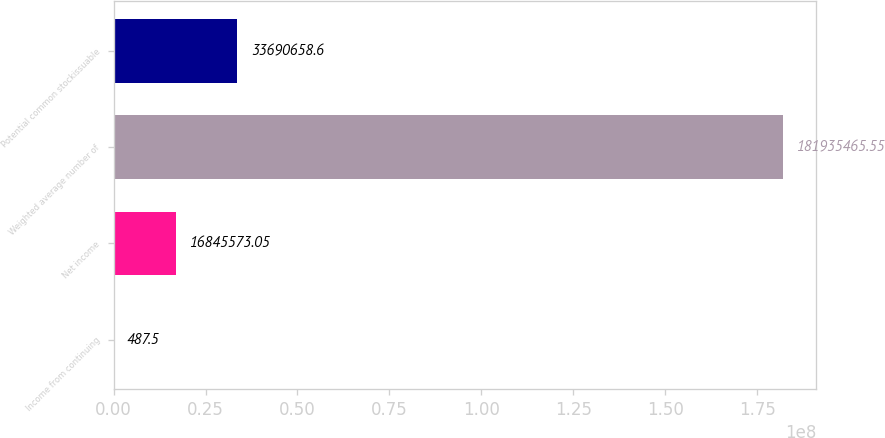Convert chart to OTSL. <chart><loc_0><loc_0><loc_500><loc_500><bar_chart><fcel>Income from continuing<fcel>Net income<fcel>Weighted average number of<fcel>Potential common stockissuable<nl><fcel>487.5<fcel>1.68456e+07<fcel>1.81935e+08<fcel>3.36907e+07<nl></chart> 